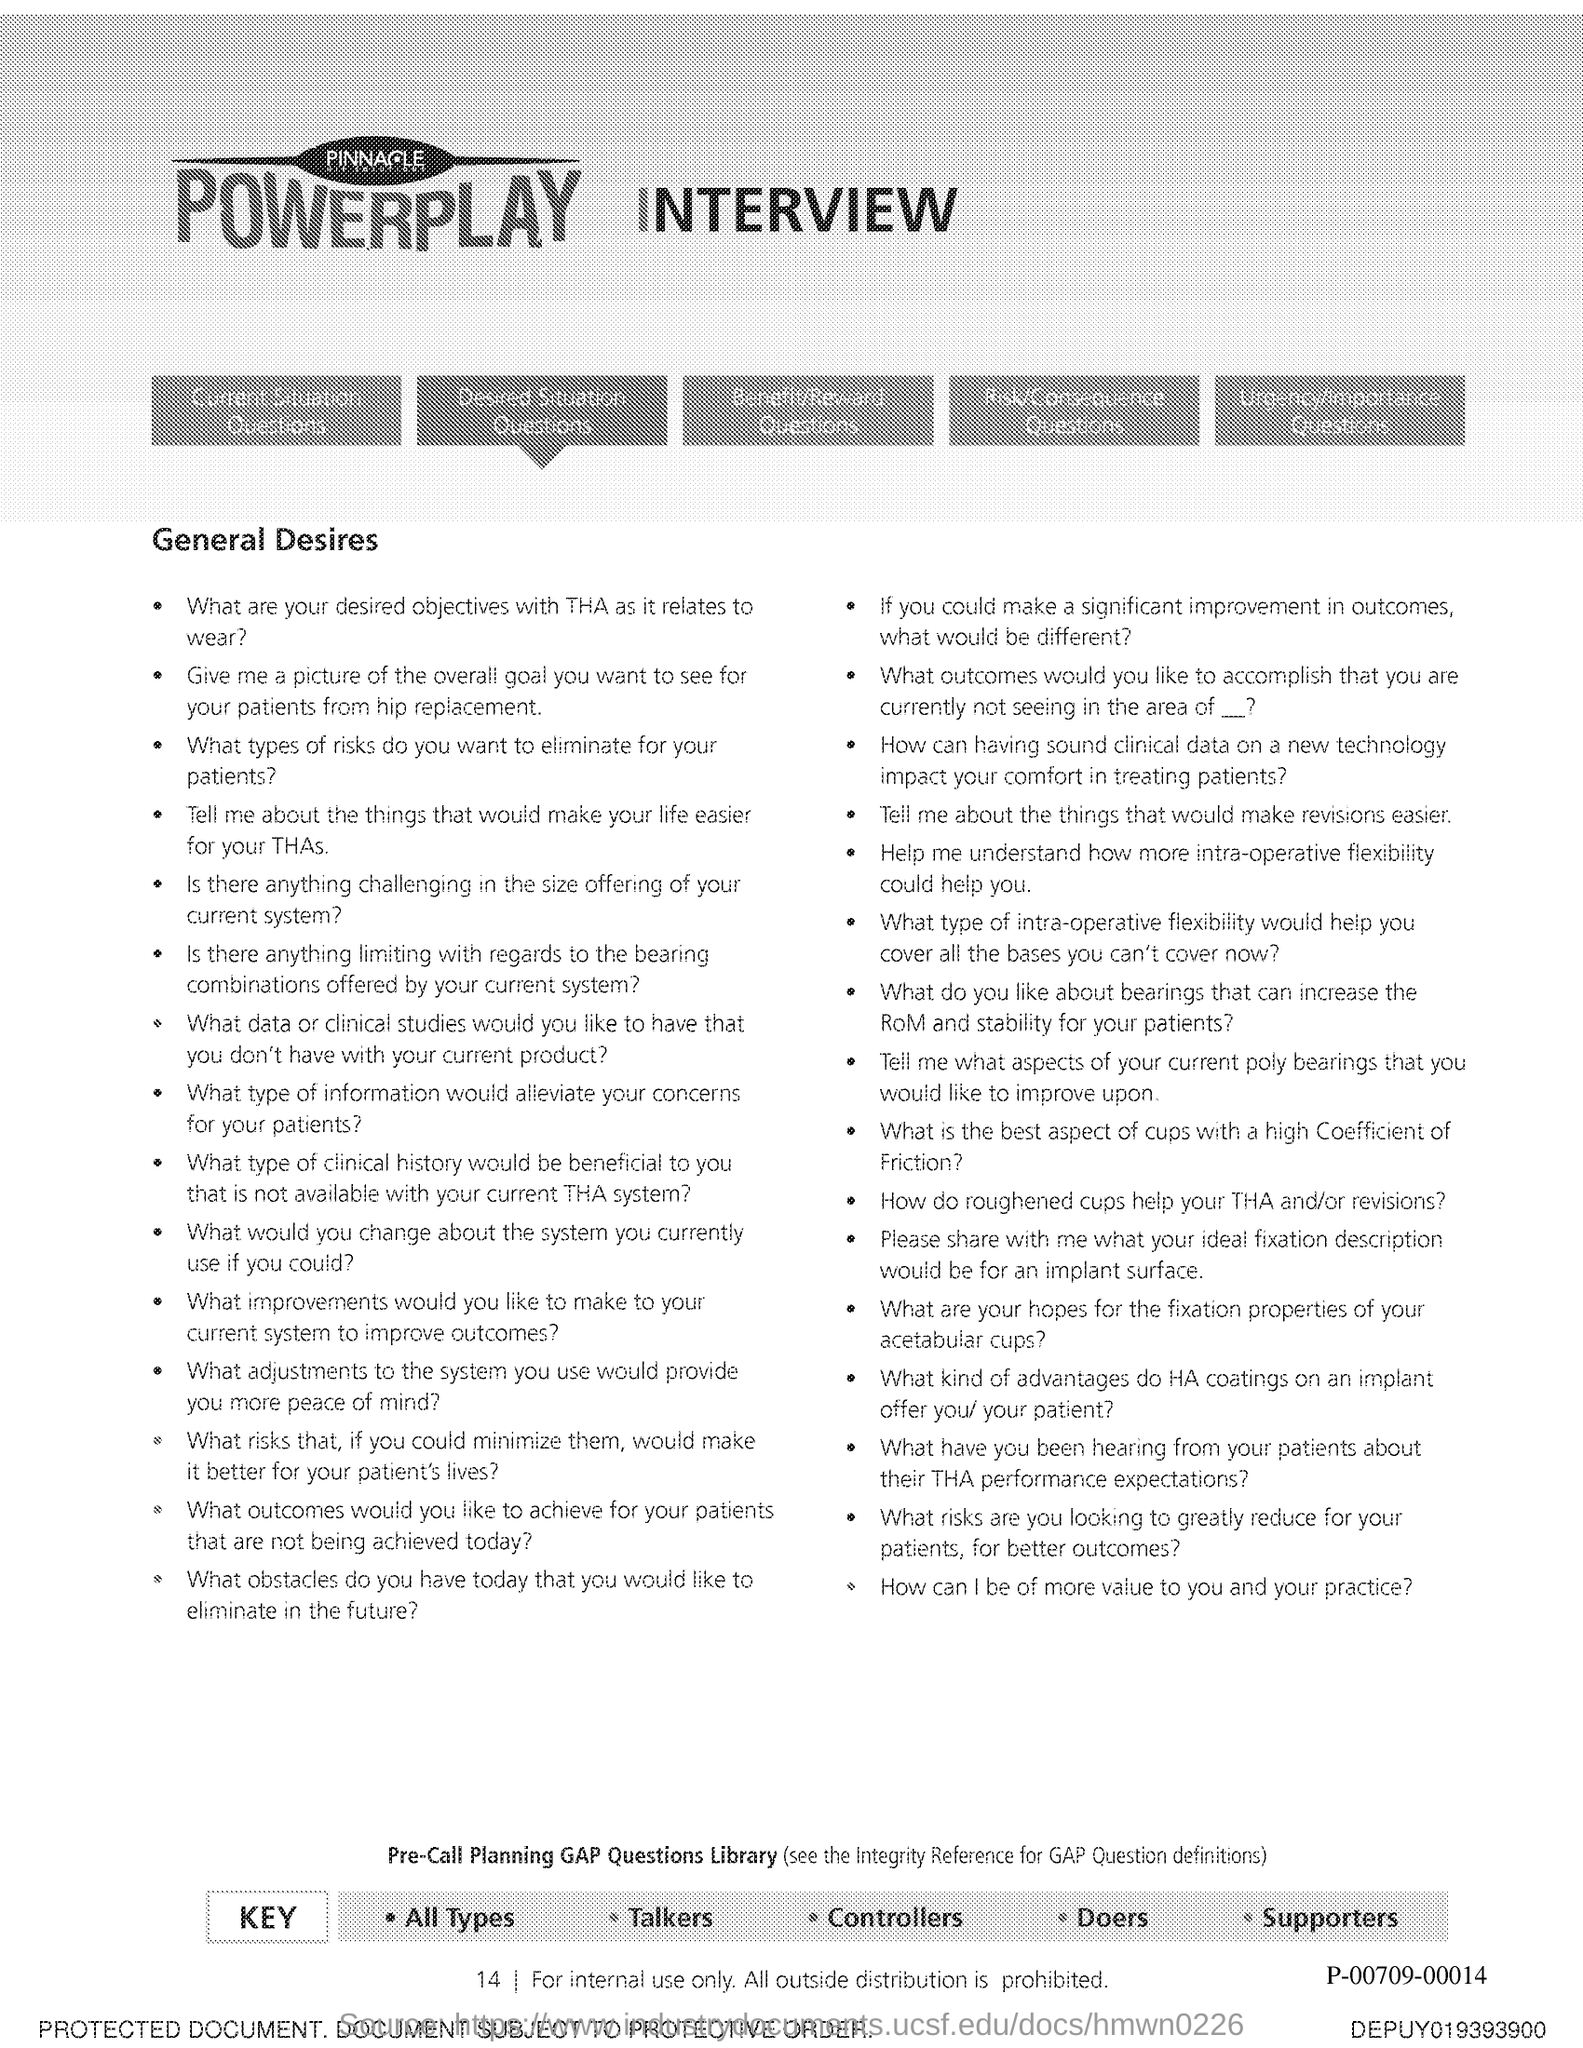What is the Page Number?
Your answer should be compact. 14. 